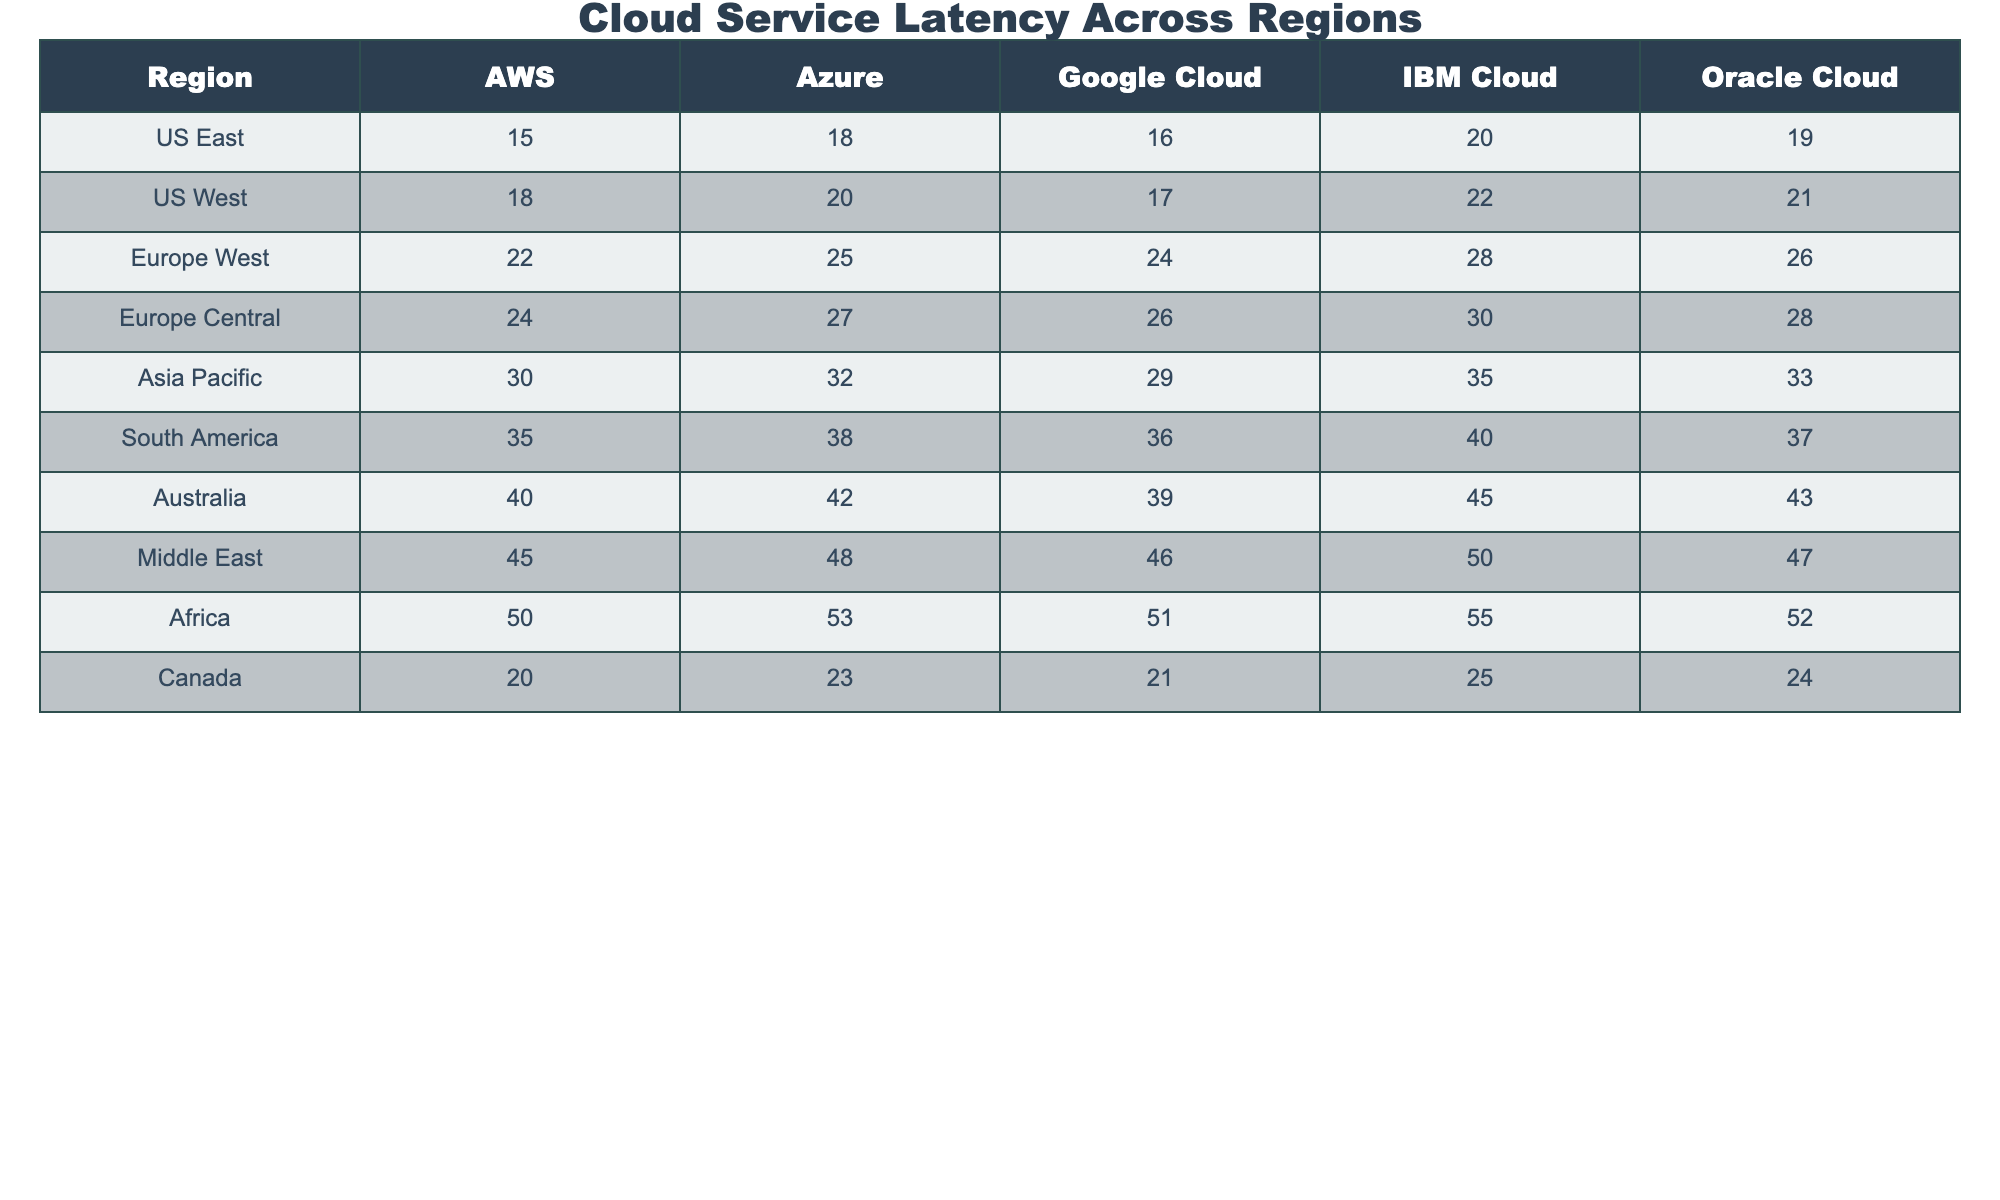What is the latency for AWS in the Asia Pacific region? The table shows the latency measurements, and for AWS in the Asia Pacific region, the value is 30.
Answer: 30 What is the lowest latency recorded for Oracle Cloud? By scanning the table, Oracle Cloud has the lowest latency of 19, which is in the US East region.
Answer: 19 Which region has the highest latency for Google Cloud? The table indicates the latency for Google Cloud is highest in South America at 36.
Answer: 36 Is the latency for Azure in Europe West greater than that of AWS in Asia Pacific? The latency for Azure in Europe West is 25, while the latency for AWS in Asia Pacific is 30. Since 25 is not greater than 30, the answer is no.
Answer: No What is the average latency for IBM Cloud across all regions? The latencies for IBM Cloud are 20, 22, 28, 30, 35, 40, 50, 55, 25. Adding these values gives a total of  20 + 22 + 28 + 30 + 35 + 40 + 50 + 55 + 25 =  305. There are 9 regions, so the average is 305 / 9 ≈ 33.89.
Answer: Approximately 33.89 Which cloud service has the highest average latency across all regions? First, we find the average latency for each cloud service: AWS (30.33), Azure (32.67), Google Cloud (30.22), IBM Cloud (40.56), Oracle Cloud (32.11). The highest average latency is for IBM Cloud.
Answer: IBM Cloud What is the difference in latency between the US West and Europe Central regions for Google Cloud? For Google Cloud, the latency in US West is 17 and in Europe Central is 26. The difference is 26 - 17 = 9.
Answer: 9 In how many regions does Oracle Cloud have a latency greater than 30? Checking the table, the Oracle Cloud latencies greater than 30 are seen in Asia Pacific (35), South America (40), Australia (45), and Africa (55), which totals 4 regions.
Answer: 4 Which region shows the lowest latency for cloud services overall? Scanning the first column reveals that the US East has the lowest latency of 15 for AWS, which is lower than all corresponding latencies in other regions.
Answer: US East 